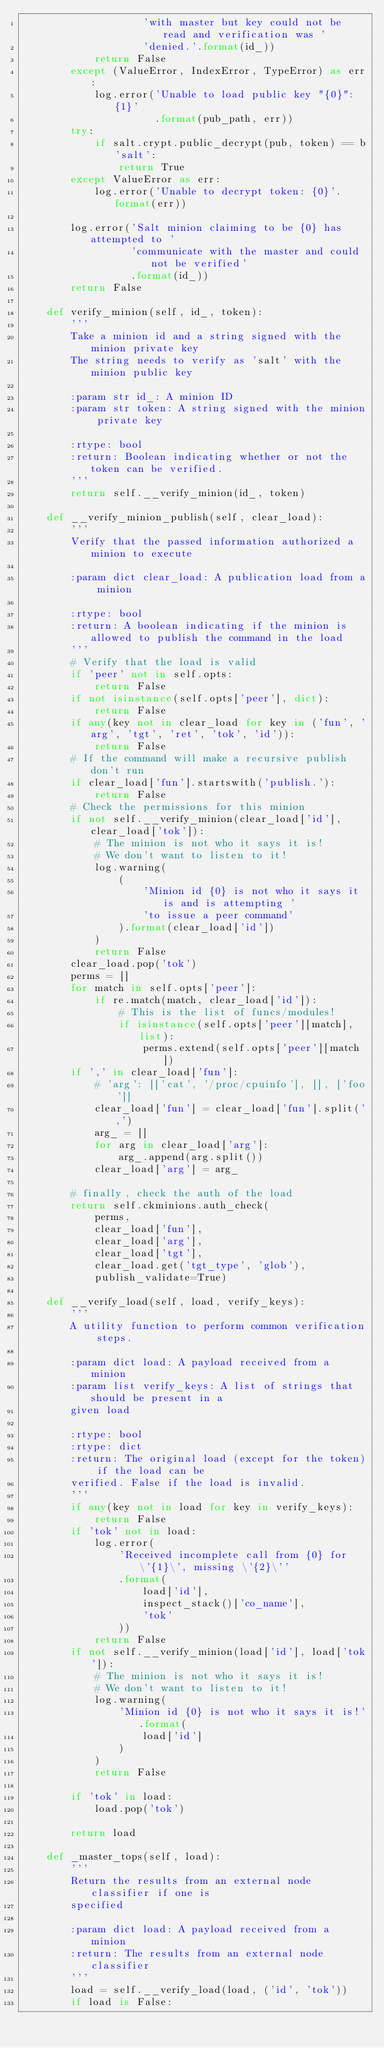<code> <loc_0><loc_0><loc_500><loc_500><_Python_>                    'with master but key could not be read and verification was '
                    'denied.'.format(id_))
            return False
        except (ValueError, IndexError, TypeError) as err:
            log.error('Unable to load public key "{0}": {1}'
                      .format(pub_path, err))
        try:
            if salt.crypt.public_decrypt(pub, token) == b'salt':
                return True
        except ValueError as err:
            log.error('Unable to decrypt token: {0}'.format(err))

        log.error('Salt minion claiming to be {0} has attempted to '
                  'communicate with the master and could not be verified'
                  .format(id_))
        return False

    def verify_minion(self, id_, token):
        '''
        Take a minion id and a string signed with the minion private key
        The string needs to verify as 'salt' with the minion public key

        :param str id_: A minion ID
        :param str token: A string signed with the minion private key

        :rtype: bool
        :return: Boolean indicating whether or not the token can be verified.
        '''
        return self.__verify_minion(id_, token)

    def __verify_minion_publish(self, clear_load):
        '''
        Verify that the passed information authorized a minion to execute

        :param dict clear_load: A publication load from a minion

        :rtype: bool
        :return: A boolean indicating if the minion is allowed to publish the command in the load
        '''
        # Verify that the load is valid
        if 'peer' not in self.opts:
            return False
        if not isinstance(self.opts['peer'], dict):
            return False
        if any(key not in clear_load for key in ('fun', 'arg', 'tgt', 'ret', 'tok', 'id')):
            return False
        # If the command will make a recursive publish don't run
        if clear_load['fun'].startswith('publish.'):
            return False
        # Check the permissions for this minion
        if not self.__verify_minion(clear_load['id'], clear_load['tok']):
            # The minion is not who it says it is!
            # We don't want to listen to it!
            log.warning(
                (
                    'Minion id {0} is not who it says it is and is attempting '
                    'to issue a peer command'
                ).format(clear_load['id'])
            )
            return False
        clear_load.pop('tok')
        perms = []
        for match in self.opts['peer']:
            if re.match(match, clear_load['id']):
                # This is the list of funcs/modules!
                if isinstance(self.opts['peer'][match], list):
                    perms.extend(self.opts['peer'][match])
        if ',' in clear_load['fun']:
            # 'arg': [['cat', '/proc/cpuinfo'], [], ['foo']]
            clear_load['fun'] = clear_load['fun'].split(',')
            arg_ = []
            for arg in clear_load['arg']:
                arg_.append(arg.split())
            clear_load['arg'] = arg_

        # finally, check the auth of the load
        return self.ckminions.auth_check(
            perms,
            clear_load['fun'],
            clear_load['arg'],
            clear_load['tgt'],
            clear_load.get('tgt_type', 'glob'),
            publish_validate=True)

    def __verify_load(self, load, verify_keys):
        '''
        A utility function to perform common verification steps.

        :param dict load: A payload received from a minion
        :param list verify_keys: A list of strings that should be present in a
        given load

        :rtype: bool
        :rtype: dict
        :return: The original load (except for the token) if the load can be
        verified. False if the load is invalid.
        '''
        if any(key not in load for key in verify_keys):
            return False
        if 'tok' not in load:
            log.error(
                'Received incomplete call from {0} for \'{1}\', missing \'{2}\''
                .format(
                    load['id'],
                    inspect_stack()['co_name'],
                    'tok'
                ))
            return False
        if not self.__verify_minion(load['id'], load['tok']):
            # The minion is not who it says it is!
            # We don't want to listen to it!
            log.warning(
                'Minion id {0} is not who it says it is!'.format(
                    load['id']
                )
            )
            return False

        if 'tok' in load:
            load.pop('tok')

        return load

    def _master_tops(self, load):
        '''
        Return the results from an external node classifier if one is
        specified

        :param dict load: A payload received from a minion
        :return: The results from an external node classifier
        '''
        load = self.__verify_load(load, ('id', 'tok'))
        if load is False:</code> 